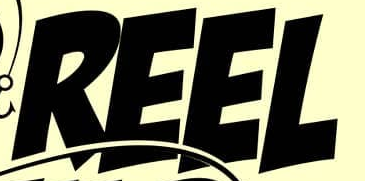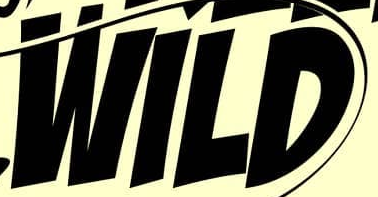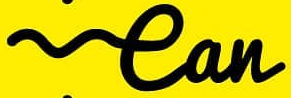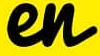What words are shown in these images in order, separated by a semicolon? REEL; WILD; ean; en 